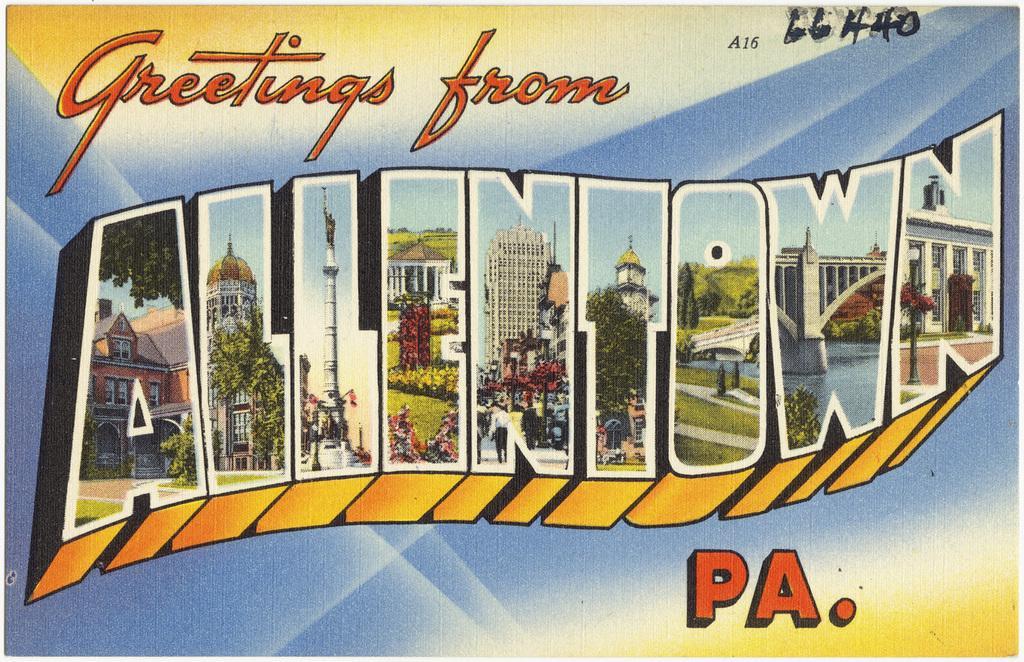Can you describe this image briefly? In this image there is a poster, on which we can see view of buildings and trees in the letters, also there are some other letters. 